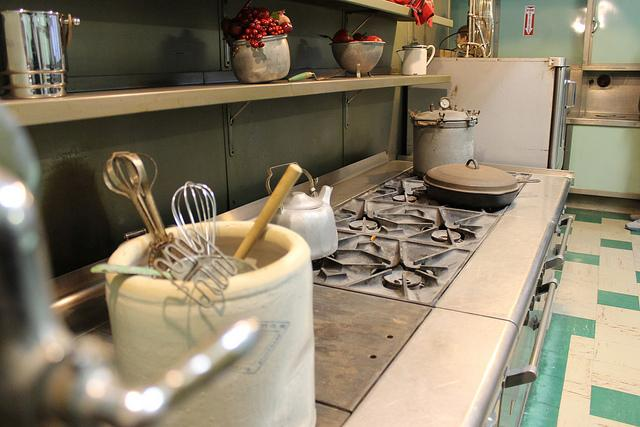What could the pot with the round white gauge on top be used for? Please explain your reasoning. canning fruit. The pot could be used for canning purposes since it has a preserving lid. 